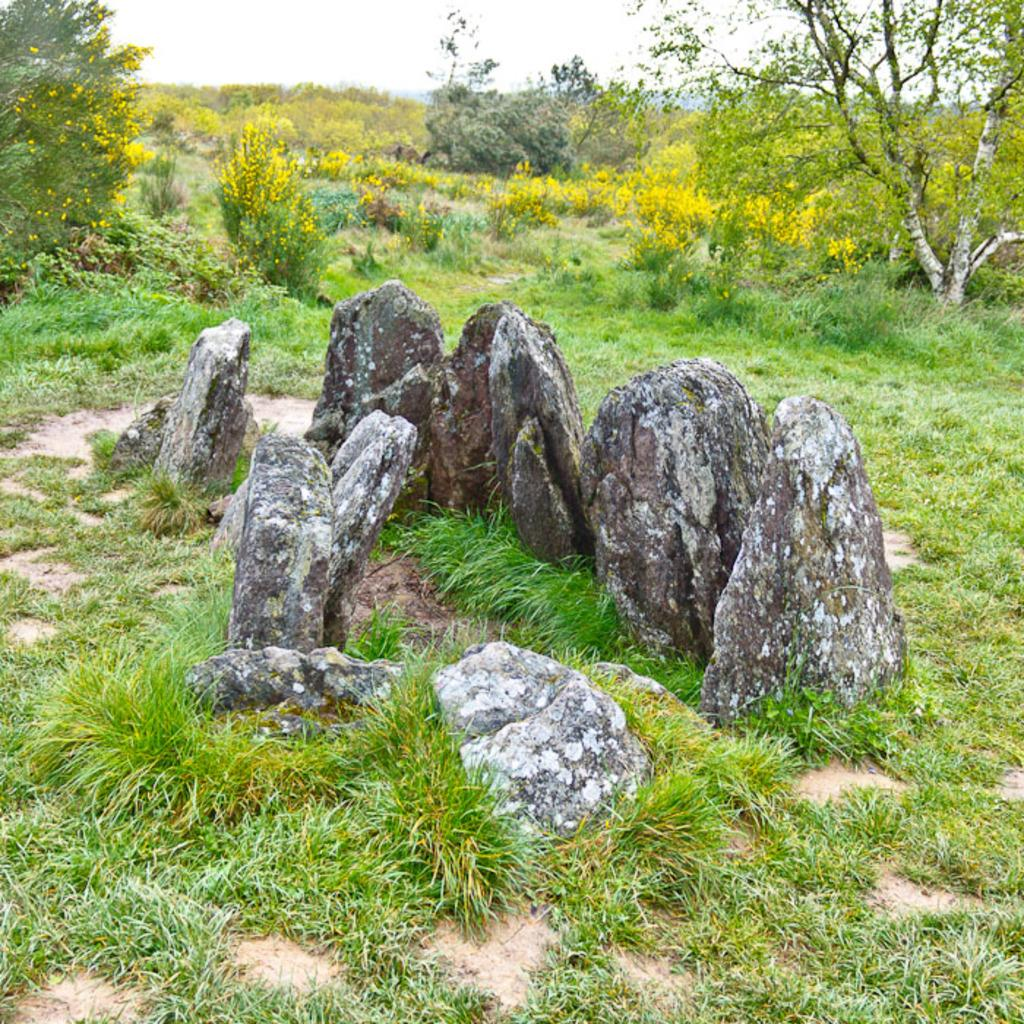What type of natural elements can be seen on the ground in the image? There are many stones on the ground in the image. What type of flowers can be seen in the image? Yellow color flowers are visible in the image. What type of vegetation is present in the image? Plants and trees are visible in the image. What type of ground cover is present at the bottom of the image? Grass is present at the bottom of the image. What part of the natural environment is visible at the top of the image? The sky is visible at the top of the image. What is the way that the disgust is expressed in the image? There is no expression of disgust present in the image. What type of afterthought is depicted in the image? There is no afterthought depicted in the image. 